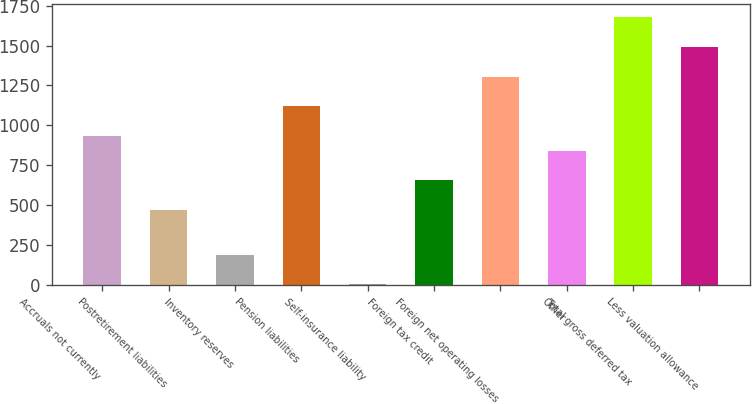<chart> <loc_0><loc_0><loc_500><loc_500><bar_chart><fcel>Accruals not currently<fcel>Postretirement liabilities<fcel>Inventory reserves<fcel>Pension liabilities<fcel>Self-insurance liability<fcel>Foreign tax credit<fcel>Foreign net operating losses<fcel>Other<fcel>Total gross deferred tax<fcel>Less valuation allowance<nl><fcel>934<fcel>468.7<fcel>189.52<fcel>1120.12<fcel>3.4<fcel>654.82<fcel>1306.24<fcel>840.94<fcel>1678.48<fcel>1492.36<nl></chart> 